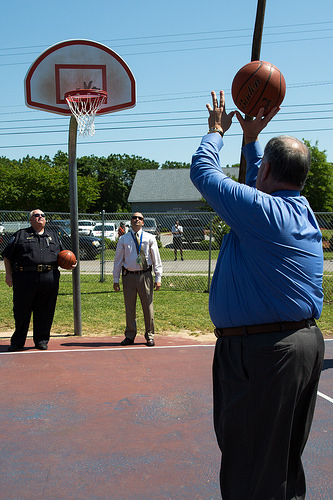<image>
Can you confirm if the ball is in front of the man? Yes. The ball is positioned in front of the man, appearing closer to the camera viewpoint. 